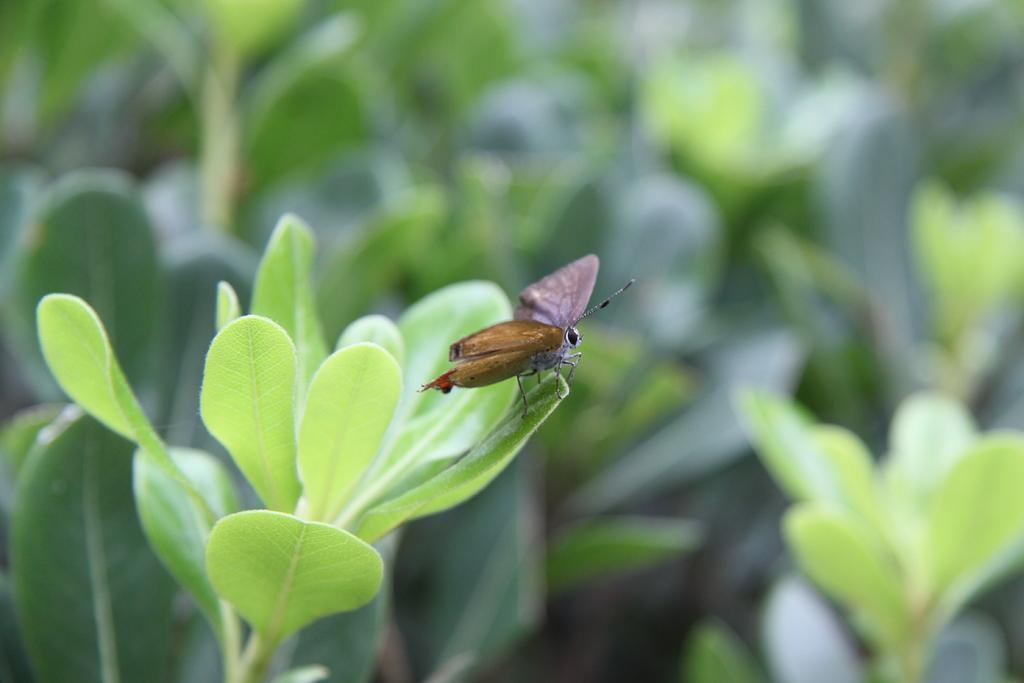What type of living organism can be seen in the image with leaves? There is a plant with leaves in the image. What other living organism can be seen in the image? There is a moth in the image. What are the main features of the moth? The moth has wings, legs, and antenna. What type of process does the plant use to achieve photosynthesis in the image? The image does not provide information about the process of photosynthesis in the plant. 